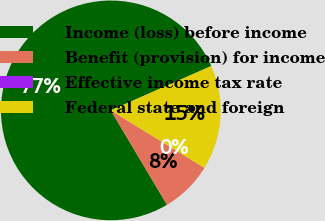Convert chart to OTSL. <chart><loc_0><loc_0><loc_500><loc_500><pie_chart><fcel>Income (loss) before income<fcel>Benefit (provision) for income<fcel>Effective income tax rate<fcel>Federal state and foreign<nl><fcel>76.92%<fcel>7.69%<fcel>0.0%<fcel>15.38%<nl></chart> 